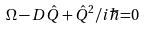Convert formula to latex. <formula><loc_0><loc_0><loc_500><loc_500>\Omega - D \hat { Q } + \hat { Q } ^ { 2 } / i \hbar { = } 0</formula> 